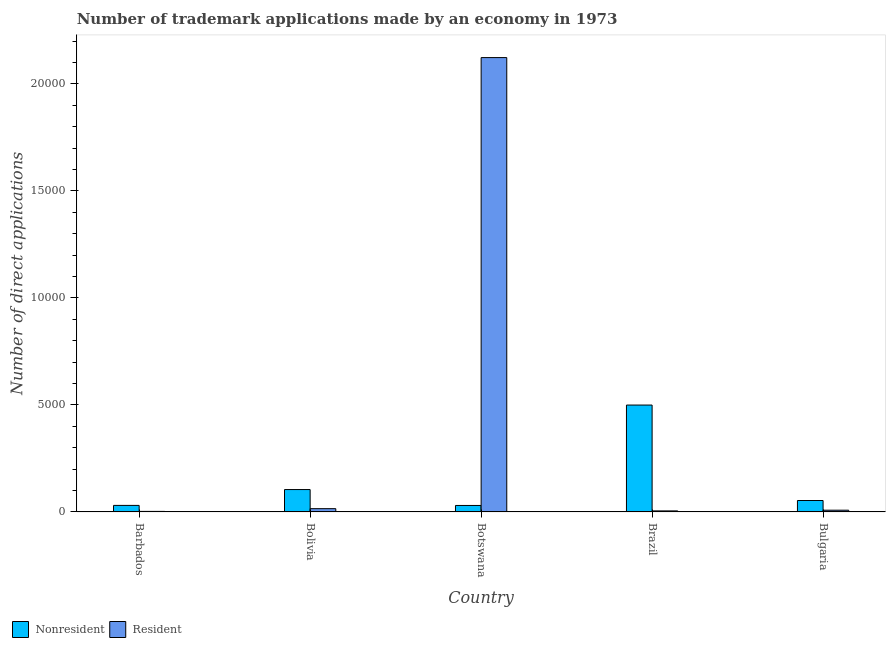How many different coloured bars are there?
Ensure brevity in your answer.  2. How many groups of bars are there?
Your answer should be very brief. 5. Are the number of bars per tick equal to the number of legend labels?
Offer a terse response. Yes. How many bars are there on the 5th tick from the right?
Ensure brevity in your answer.  2. What is the label of the 1st group of bars from the left?
Your response must be concise. Barbados. In how many cases, is the number of bars for a given country not equal to the number of legend labels?
Your answer should be compact. 0. What is the number of trademark applications made by residents in Bulgaria?
Your answer should be compact. 80. Across all countries, what is the maximum number of trademark applications made by non residents?
Ensure brevity in your answer.  4994. Across all countries, what is the minimum number of trademark applications made by residents?
Keep it short and to the point. 24. In which country was the number of trademark applications made by residents maximum?
Keep it short and to the point. Botswana. In which country was the number of trademark applications made by non residents minimum?
Provide a short and direct response. Botswana. What is the total number of trademark applications made by non residents in the graph?
Your answer should be very brief. 7177. What is the difference between the number of trademark applications made by non residents in Barbados and that in Brazil?
Offer a very short reply. -4690. What is the difference between the number of trademark applications made by non residents in Brazil and the number of trademark applications made by residents in Botswana?
Offer a terse response. -1.62e+04. What is the average number of trademark applications made by residents per country?
Provide a succinct answer. 4307.2. What is the difference between the number of trademark applications made by non residents and number of trademark applications made by residents in Bolivia?
Your answer should be very brief. 893. In how many countries, is the number of trademark applications made by residents greater than 2000 ?
Give a very brief answer. 1. What is the ratio of the number of trademark applications made by non residents in Barbados to that in Brazil?
Make the answer very short. 0.06. What is the difference between the highest and the second highest number of trademark applications made by residents?
Give a very brief answer. 2.11e+04. What is the difference between the highest and the lowest number of trademark applications made by non residents?
Your answer should be compact. 4693. Is the sum of the number of trademark applications made by residents in Barbados and Brazil greater than the maximum number of trademark applications made by non residents across all countries?
Provide a short and direct response. No. What does the 2nd bar from the left in Botswana represents?
Your response must be concise. Resident. What does the 1st bar from the right in Bolivia represents?
Give a very brief answer. Resident. How many bars are there?
Your answer should be very brief. 10. Does the graph contain any zero values?
Your answer should be very brief. No. How many legend labels are there?
Your answer should be very brief. 2. How are the legend labels stacked?
Your answer should be very brief. Horizontal. What is the title of the graph?
Keep it short and to the point. Number of trademark applications made by an economy in 1973. Does "Food" appear as one of the legend labels in the graph?
Keep it short and to the point. No. What is the label or title of the Y-axis?
Your answer should be very brief. Number of direct applications. What is the Number of direct applications in Nonresident in Barbados?
Make the answer very short. 304. What is the Number of direct applications in Nonresident in Bolivia?
Keep it short and to the point. 1045. What is the Number of direct applications in Resident in Bolivia?
Make the answer very short. 152. What is the Number of direct applications of Nonresident in Botswana?
Provide a short and direct response. 301. What is the Number of direct applications in Resident in Botswana?
Provide a succinct answer. 2.12e+04. What is the Number of direct applications in Nonresident in Brazil?
Keep it short and to the point. 4994. What is the Number of direct applications in Resident in Brazil?
Provide a short and direct response. 47. What is the Number of direct applications in Nonresident in Bulgaria?
Offer a terse response. 533. What is the Number of direct applications of Resident in Bulgaria?
Give a very brief answer. 80. Across all countries, what is the maximum Number of direct applications in Nonresident?
Keep it short and to the point. 4994. Across all countries, what is the maximum Number of direct applications in Resident?
Keep it short and to the point. 2.12e+04. Across all countries, what is the minimum Number of direct applications of Nonresident?
Your answer should be very brief. 301. Across all countries, what is the minimum Number of direct applications of Resident?
Offer a very short reply. 24. What is the total Number of direct applications of Nonresident in the graph?
Your answer should be very brief. 7177. What is the total Number of direct applications in Resident in the graph?
Your response must be concise. 2.15e+04. What is the difference between the Number of direct applications in Nonresident in Barbados and that in Bolivia?
Provide a short and direct response. -741. What is the difference between the Number of direct applications in Resident in Barbados and that in Bolivia?
Offer a terse response. -128. What is the difference between the Number of direct applications in Resident in Barbados and that in Botswana?
Make the answer very short. -2.12e+04. What is the difference between the Number of direct applications of Nonresident in Barbados and that in Brazil?
Provide a succinct answer. -4690. What is the difference between the Number of direct applications of Nonresident in Barbados and that in Bulgaria?
Provide a succinct answer. -229. What is the difference between the Number of direct applications in Resident in Barbados and that in Bulgaria?
Offer a very short reply. -56. What is the difference between the Number of direct applications of Nonresident in Bolivia and that in Botswana?
Keep it short and to the point. 744. What is the difference between the Number of direct applications of Resident in Bolivia and that in Botswana?
Your response must be concise. -2.11e+04. What is the difference between the Number of direct applications in Nonresident in Bolivia and that in Brazil?
Your answer should be compact. -3949. What is the difference between the Number of direct applications in Resident in Bolivia and that in Brazil?
Give a very brief answer. 105. What is the difference between the Number of direct applications of Nonresident in Bolivia and that in Bulgaria?
Offer a terse response. 512. What is the difference between the Number of direct applications of Nonresident in Botswana and that in Brazil?
Provide a short and direct response. -4693. What is the difference between the Number of direct applications in Resident in Botswana and that in Brazil?
Ensure brevity in your answer.  2.12e+04. What is the difference between the Number of direct applications in Nonresident in Botswana and that in Bulgaria?
Offer a terse response. -232. What is the difference between the Number of direct applications of Resident in Botswana and that in Bulgaria?
Your answer should be compact. 2.12e+04. What is the difference between the Number of direct applications in Nonresident in Brazil and that in Bulgaria?
Make the answer very short. 4461. What is the difference between the Number of direct applications in Resident in Brazil and that in Bulgaria?
Provide a short and direct response. -33. What is the difference between the Number of direct applications in Nonresident in Barbados and the Number of direct applications in Resident in Bolivia?
Keep it short and to the point. 152. What is the difference between the Number of direct applications in Nonresident in Barbados and the Number of direct applications in Resident in Botswana?
Your answer should be very brief. -2.09e+04. What is the difference between the Number of direct applications of Nonresident in Barbados and the Number of direct applications of Resident in Brazil?
Keep it short and to the point. 257. What is the difference between the Number of direct applications of Nonresident in Barbados and the Number of direct applications of Resident in Bulgaria?
Keep it short and to the point. 224. What is the difference between the Number of direct applications in Nonresident in Bolivia and the Number of direct applications in Resident in Botswana?
Your answer should be compact. -2.02e+04. What is the difference between the Number of direct applications in Nonresident in Bolivia and the Number of direct applications in Resident in Brazil?
Ensure brevity in your answer.  998. What is the difference between the Number of direct applications of Nonresident in Bolivia and the Number of direct applications of Resident in Bulgaria?
Make the answer very short. 965. What is the difference between the Number of direct applications of Nonresident in Botswana and the Number of direct applications of Resident in Brazil?
Keep it short and to the point. 254. What is the difference between the Number of direct applications in Nonresident in Botswana and the Number of direct applications in Resident in Bulgaria?
Make the answer very short. 221. What is the difference between the Number of direct applications of Nonresident in Brazil and the Number of direct applications of Resident in Bulgaria?
Keep it short and to the point. 4914. What is the average Number of direct applications in Nonresident per country?
Your answer should be very brief. 1435.4. What is the average Number of direct applications of Resident per country?
Make the answer very short. 4307.2. What is the difference between the Number of direct applications in Nonresident and Number of direct applications in Resident in Barbados?
Provide a succinct answer. 280. What is the difference between the Number of direct applications in Nonresident and Number of direct applications in Resident in Bolivia?
Your answer should be compact. 893. What is the difference between the Number of direct applications of Nonresident and Number of direct applications of Resident in Botswana?
Your answer should be compact. -2.09e+04. What is the difference between the Number of direct applications in Nonresident and Number of direct applications in Resident in Brazil?
Your answer should be compact. 4947. What is the difference between the Number of direct applications in Nonresident and Number of direct applications in Resident in Bulgaria?
Make the answer very short. 453. What is the ratio of the Number of direct applications of Nonresident in Barbados to that in Bolivia?
Offer a terse response. 0.29. What is the ratio of the Number of direct applications in Resident in Barbados to that in Bolivia?
Ensure brevity in your answer.  0.16. What is the ratio of the Number of direct applications of Resident in Barbados to that in Botswana?
Provide a short and direct response. 0. What is the ratio of the Number of direct applications in Nonresident in Barbados to that in Brazil?
Your answer should be compact. 0.06. What is the ratio of the Number of direct applications of Resident in Barbados to that in Brazil?
Your answer should be compact. 0.51. What is the ratio of the Number of direct applications of Nonresident in Barbados to that in Bulgaria?
Your answer should be very brief. 0.57. What is the ratio of the Number of direct applications in Resident in Barbados to that in Bulgaria?
Ensure brevity in your answer.  0.3. What is the ratio of the Number of direct applications in Nonresident in Bolivia to that in Botswana?
Provide a succinct answer. 3.47. What is the ratio of the Number of direct applications in Resident in Bolivia to that in Botswana?
Provide a short and direct response. 0.01. What is the ratio of the Number of direct applications in Nonresident in Bolivia to that in Brazil?
Provide a succinct answer. 0.21. What is the ratio of the Number of direct applications of Resident in Bolivia to that in Brazil?
Offer a very short reply. 3.23. What is the ratio of the Number of direct applications in Nonresident in Bolivia to that in Bulgaria?
Offer a terse response. 1.96. What is the ratio of the Number of direct applications of Resident in Bolivia to that in Bulgaria?
Offer a very short reply. 1.9. What is the ratio of the Number of direct applications of Nonresident in Botswana to that in Brazil?
Your answer should be very brief. 0.06. What is the ratio of the Number of direct applications in Resident in Botswana to that in Brazil?
Your response must be concise. 451.77. What is the ratio of the Number of direct applications of Nonresident in Botswana to that in Bulgaria?
Your answer should be very brief. 0.56. What is the ratio of the Number of direct applications of Resident in Botswana to that in Bulgaria?
Your answer should be very brief. 265.41. What is the ratio of the Number of direct applications of Nonresident in Brazil to that in Bulgaria?
Make the answer very short. 9.37. What is the ratio of the Number of direct applications in Resident in Brazil to that in Bulgaria?
Offer a very short reply. 0.59. What is the difference between the highest and the second highest Number of direct applications in Nonresident?
Your response must be concise. 3949. What is the difference between the highest and the second highest Number of direct applications in Resident?
Ensure brevity in your answer.  2.11e+04. What is the difference between the highest and the lowest Number of direct applications in Nonresident?
Provide a short and direct response. 4693. What is the difference between the highest and the lowest Number of direct applications in Resident?
Provide a short and direct response. 2.12e+04. 